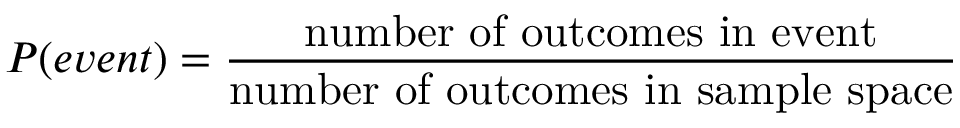<formula> <loc_0><loc_0><loc_500><loc_500>P ( e v e n t ) = { \frac { n u m b e r o f o u t c o m e s i n e v e n t } { n u m b e r o f o u t c o m e s i n s a m p l e s p a c e } }</formula> 